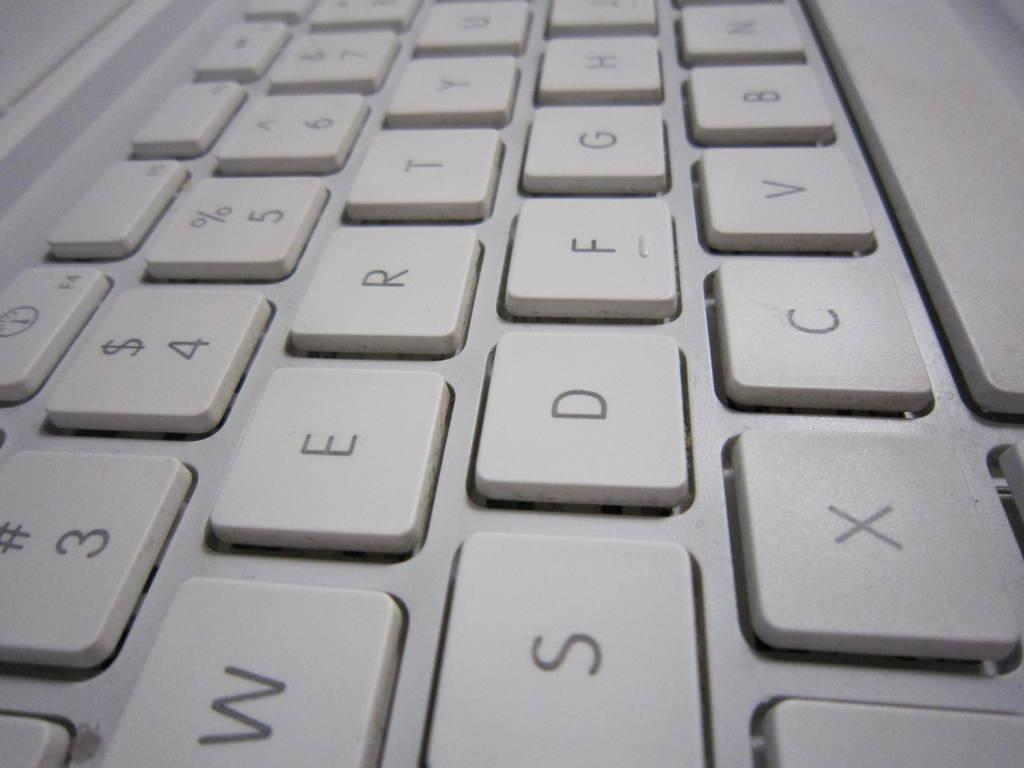<image>
Render a clear and concise summary of the photo. A computer keyboard has many keys including w, e and r. 